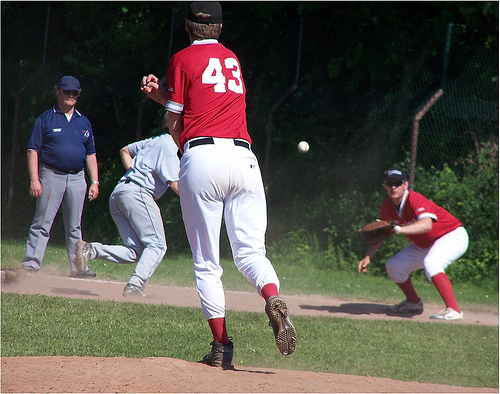<image>What brand shoes is the pitcher wearing? I am not sure what brand shoes the pitcher is wearing. It can be seen either Adidas or Nike. What brand shoes is the pitcher wearing? I am not sure what brand shoes the pitcher is wearing. It can be either adidas, nike or unknown. 